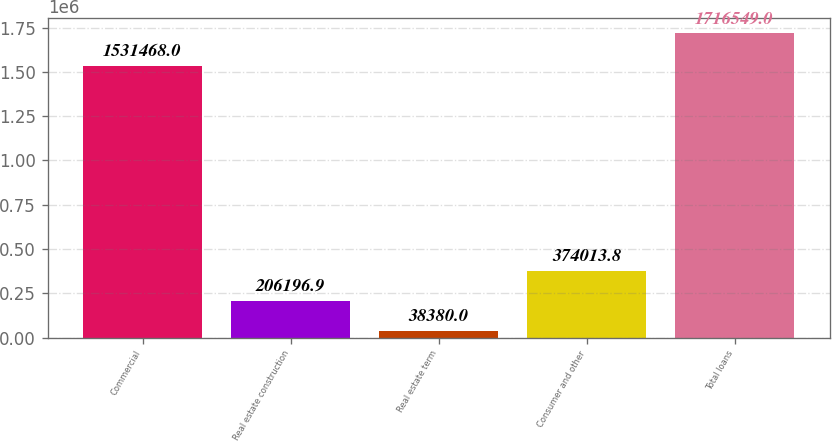<chart> <loc_0><loc_0><loc_500><loc_500><bar_chart><fcel>Commercial<fcel>Real estate construction<fcel>Real estate term<fcel>Consumer and other<fcel>Total loans<nl><fcel>1.53147e+06<fcel>206197<fcel>38380<fcel>374014<fcel>1.71655e+06<nl></chart> 